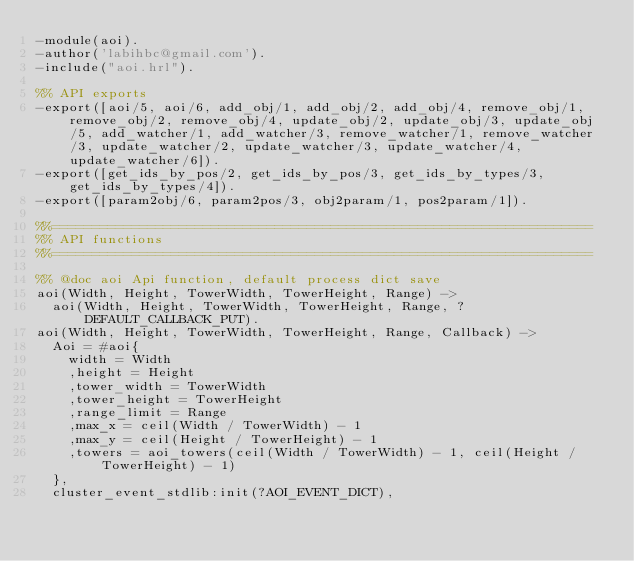Convert code to text. <code><loc_0><loc_0><loc_500><loc_500><_Erlang_>-module(aoi).
-author('labihbc@gmail.com').
-include("aoi.hrl").

%% API exports
-export([aoi/5, aoi/6, add_obj/1, add_obj/2, add_obj/4, remove_obj/1, remove_obj/2, remove_obj/4, update_obj/2, update_obj/3, update_obj/5, add_watcher/1, add_watcher/3, remove_watcher/1, remove_watcher/3, update_watcher/2, update_watcher/3, update_watcher/4, update_watcher/6]).
-export([get_ids_by_pos/2, get_ids_by_pos/3, get_ids_by_types/3, get_ids_by_types/4]).
-export([param2obj/6, param2pos/3, obj2param/1, pos2param/1]).

%%====================================================================
%% API functions
%%====================================================================

%% @doc aoi Api function, default process dict save
aoi(Width, Height, TowerWidth, TowerHeight, Range) ->
	aoi(Width, Height, TowerWidth, TowerHeight, Range, ?DEFAULT_CALLBACK_PUT).
aoi(Width, Height, TowerWidth, TowerHeight, Range, Callback) ->
	Aoi = #aoi{
		width = Width
		,height = Height
		,tower_width = TowerWidth
		,tower_height = TowerHeight
		,range_limit = Range
		,max_x = ceil(Width / TowerWidth) - 1
		,max_y = ceil(Height / TowerHeight) - 1
		,towers = aoi_towers(ceil(Width / TowerWidth) - 1, ceil(Height / TowerHeight) - 1)
	},
	cluster_event_stdlib:init(?AOI_EVENT_DICT),</code> 